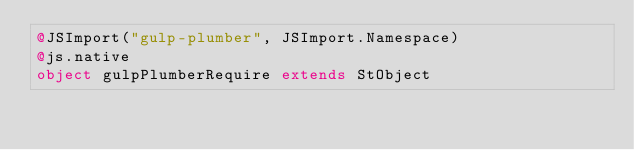Convert code to text. <code><loc_0><loc_0><loc_500><loc_500><_Scala_>@JSImport("gulp-plumber", JSImport.Namespace)
@js.native
object gulpPlumberRequire extends StObject
</code> 